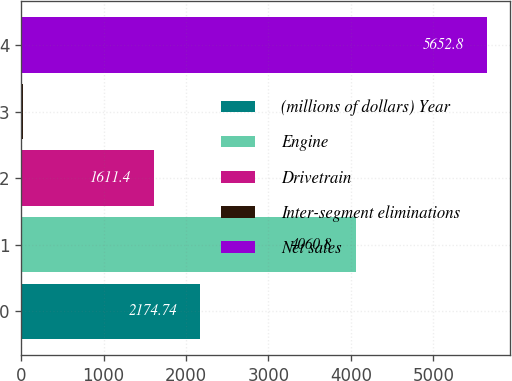Convert chart to OTSL. <chart><loc_0><loc_0><loc_500><loc_500><bar_chart><fcel>(millions of dollars) Year<fcel>Engine<fcel>Drivetrain<fcel>Inter-segment eliminations<fcel>Net sales<nl><fcel>2174.74<fcel>4060.8<fcel>1611.4<fcel>19.4<fcel>5652.8<nl></chart> 